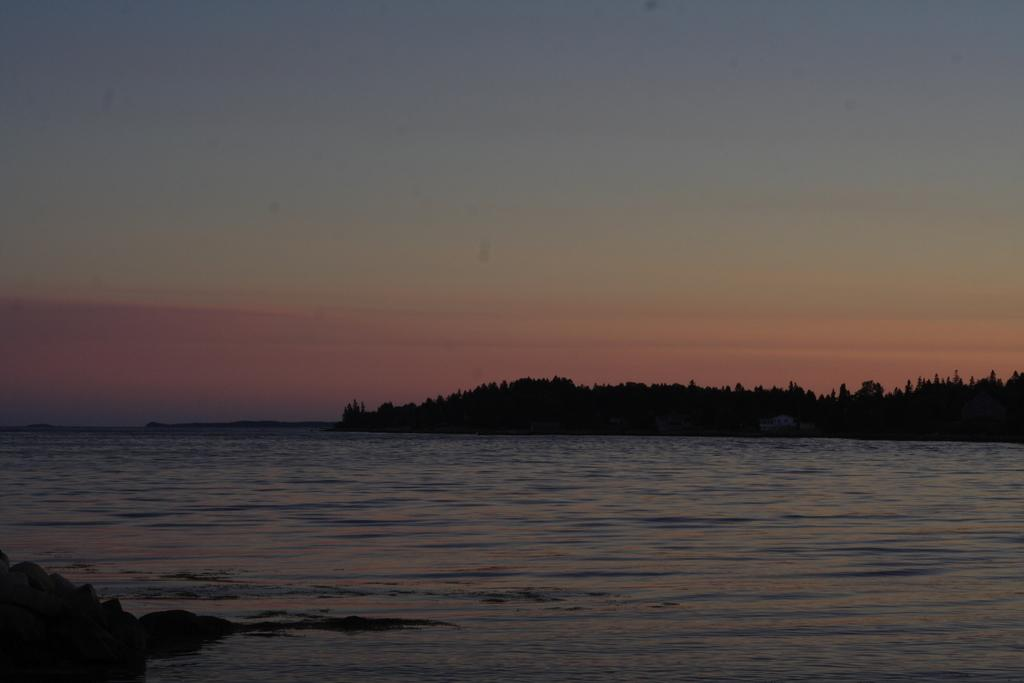Where was the image taken? The image was clicked outside the city. What natural feature can be seen in the image? There is a water body in the image. What type of vegetation is present in the image? There are trees in the image. What part of the natural environment is visible in the image? The sky is visible in the image. Can you describe any other objects in the image? There are other unspecified objects in the image. What type of kite is being flown by the person learning to fly it in the image? There is no person flying a kite in the image; it does not depict a vacation scene or any learning activity. 